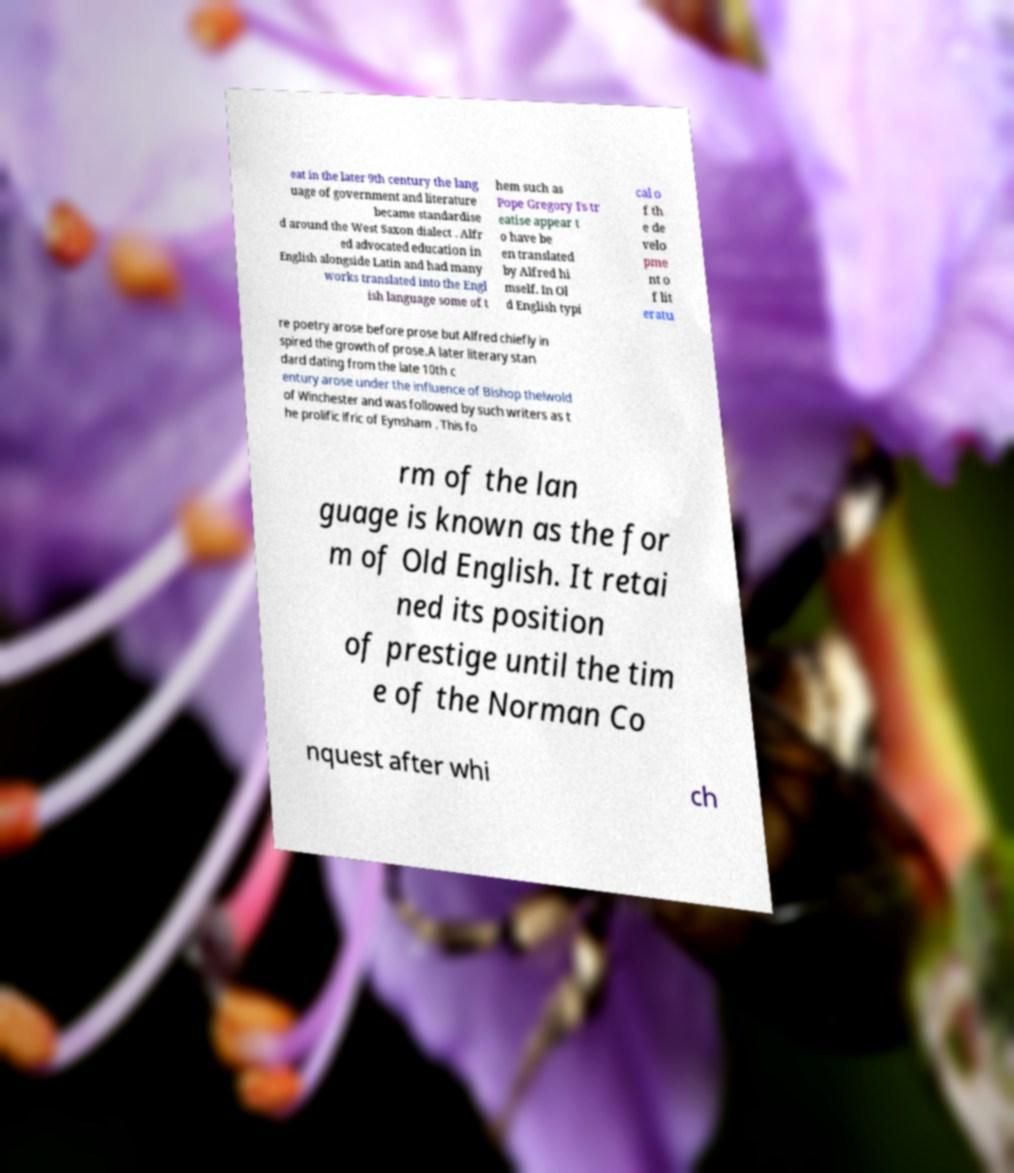For documentation purposes, I need the text within this image transcribed. Could you provide that? eat in the later 9th century the lang uage of government and literature became standardise d around the West Saxon dialect . Alfr ed advocated education in English alongside Latin and had many works translated into the Engl ish language some of t hem such as Pope Gregory I's tr eatise appear t o have be en translated by Alfred hi mself. In Ol d English typi cal o f th e de velo pme nt o f lit eratu re poetry arose before prose but Alfred chiefly in spired the growth of prose.A later literary stan dard dating from the late 10th c entury arose under the influence of Bishop thelwold of Winchester and was followed by such writers as t he prolific lfric of Eynsham . This fo rm of the lan guage is known as the for m of Old English. It retai ned its position of prestige until the tim e of the Norman Co nquest after whi ch 